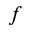Convert formula to latex. <formula><loc_0><loc_0><loc_500><loc_500>f</formula> 